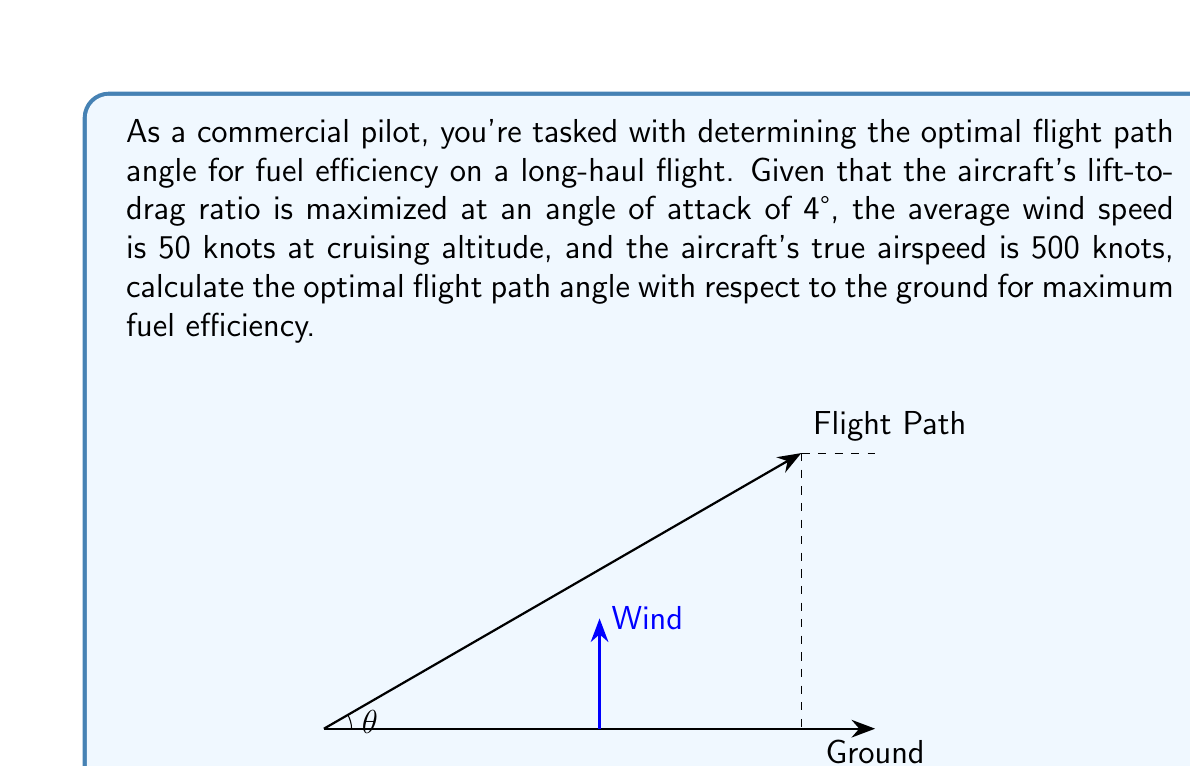Teach me how to tackle this problem. Let's approach this step-by-step:

1) The optimal flight path angle for fuel efficiency is generally the one that maximizes ground speed while maintaining the best lift-to-drag ratio.

2) We know that the best lift-to-drag ratio occurs at an angle of attack of 4°. This means the aircraft should maintain this angle relative to the air mass it's flying through.

3) However, we need to consider the wind's effect on the ground speed. The wind effectively changes the direction of the air mass relative to the ground.

4) We can use vector addition to find the optimal angle. Let's define our vectors:
   
   $\vec{v}_a$ = aircraft velocity relative to air (500 knots at 4° above horizontal)
   $\vec{v}_w$ = wind velocity (50 knots, assumed horizontal)
   $\vec{v}_g$ = ground velocity (what we want to maximize)

5) We can express these in component form:

   $\vec{v}_a = (500 \cos 4°, 500 \sin 4°)$
   $\vec{v}_w = (-50, 0)$ (assuming headwind)
   $\vec{v}_g = \vec{v}_a + \vec{v}_w$

6) Calculating:

   $\vec{v}_g = (500 \cos 4° - 50, 500 \sin 4°)$
   $\vec{v}_g \approx (448.3, 34.9)$

7) The flight path angle $\theta$ with respect to the ground is:

   $\theta = \tan^{-1}(\frac{34.9}{448.3}) \approx 4.45°$

This angle is slightly larger than the 4° angle of attack because the headwind effectively increases the climb angle relative to the ground.
Answer: $4.45°$ 